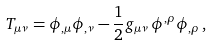Convert formula to latex. <formula><loc_0><loc_0><loc_500><loc_500>T _ { \mu \nu } = \phi _ { , \mu } \phi _ { , \nu } - \frac { 1 } { 2 } g _ { \mu \nu } \, \phi ^ { , \rho } \phi _ { , \rho } \, ,</formula> 